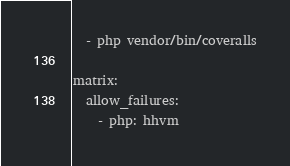Convert code to text. <code><loc_0><loc_0><loc_500><loc_500><_YAML_>  - php vendor/bin/coveralls

matrix:
  allow_failures:
    - php: hhvm
</code> 